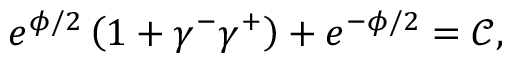Convert formula to latex. <formula><loc_0><loc_0><loc_500><loc_500>e ^ { \phi / 2 } \left ( 1 + \gamma ^ { - } \gamma ^ { + } \right ) + e ^ { - \phi / 2 } = \mathcal { C } ,</formula> 